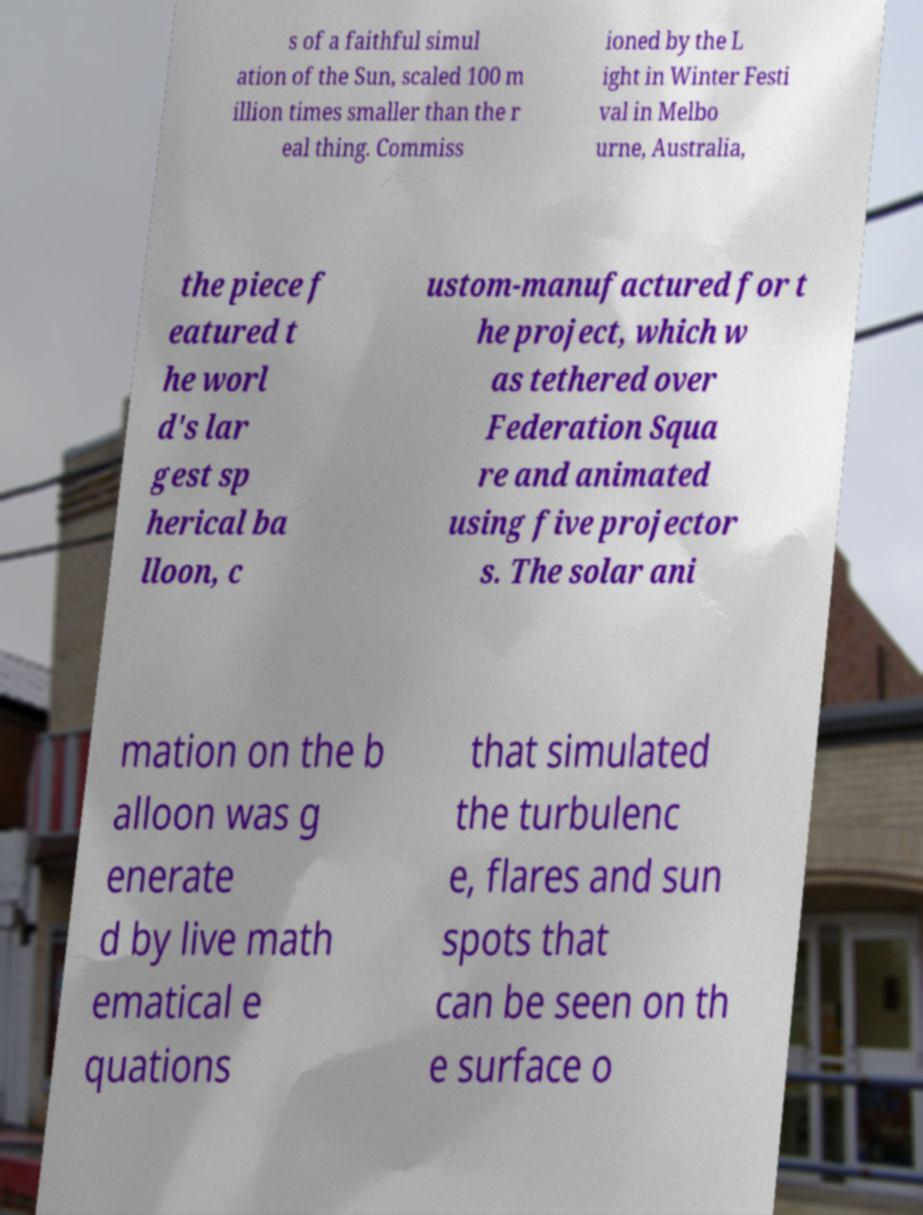Could you extract and type out the text from this image? s of a faithful simul ation of the Sun, scaled 100 m illion times smaller than the r eal thing. Commiss ioned by the L ight in Winter Festi val in Melbo urne, Australia, the piece f eatured t he worl d's lar gest sp herical ba lloon, c ustom-manufactured for t he project, which w as tethered over Federation Squa re and animated using five projector s. The solar ani mation on the b alloon was g enerate d by live math ematical e quations that simulated the turbulenc e, flares and sun spots that can be seen on th e surface o 